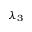Convert formula to latex. <formula><loc_0><loc_0><loc_500><loc_500>\lambda _ { 3 }</formula> 